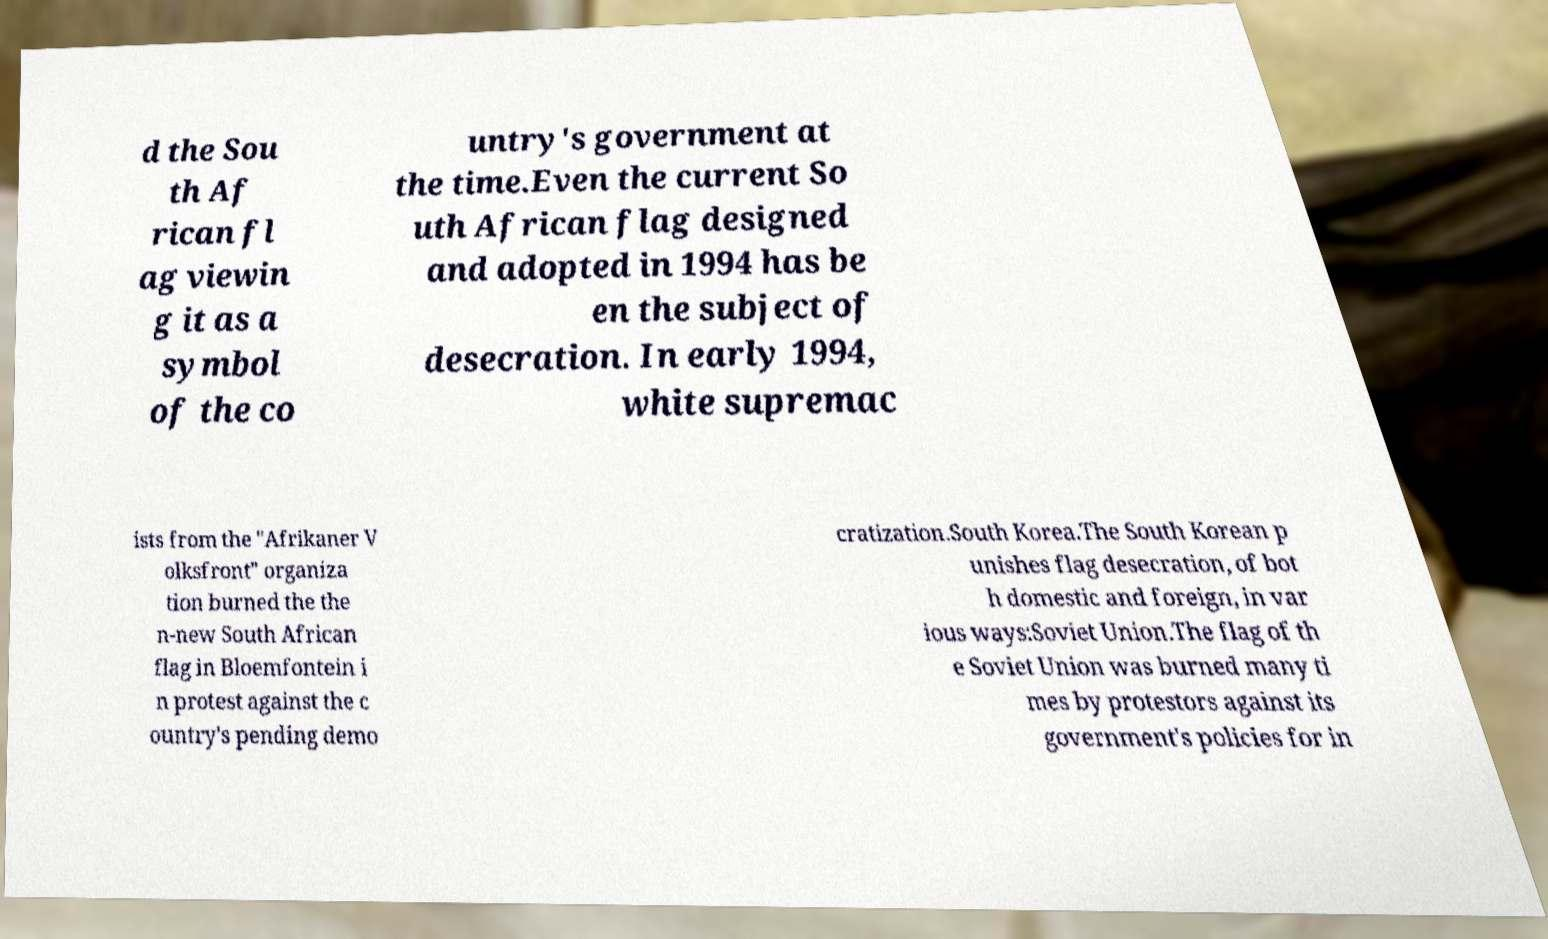Please identify and transcribe the text found in this image. d the Sou th Af rican fl ag viewin g it as a symbol of the co untry's government at the time.Even the current So uth African flag designed and adopted in 1994 has be en the subject of desecration. In early 1994, white supremac ists from the "Afrikaner V olksfront" organiza tion burned the the n-new South African flag in Bloemfontein i n protest against the c ountry's pending demo cratization.South Korea.The South Korean p unishes flag desecration, of bot h domestic and foreign, in var ious ways:Soviet Union.The flag of th e Soviet Union was burned many ti mes by protestors against its government's policies for in 